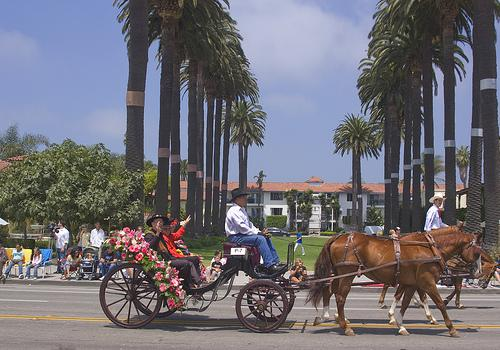Question: what are the horses pulling?
Choices:
A. A cart.
B. A plow.
C. A carriage.
D. A float in the parade.
Answer with the letter. Answer: C Question: what are the two people riding in the back of the carriage doing?
Choices:
A. Smiling.
B. Laughing.
C. Eating.
D. Waving.
Answer with the letter. Answer: D Question: where are the horses and the carriage?
Choices:
A. Down the road a block.
B. On the gravel road.
C. In the middle of the street.
D. In the grass pulled off to the side.
Answer with the letter. Answer: C Question: what kind of trees are the tall ones?
Choices:
A. Pine.
B. Oak.
C. Palm.
D. Maple.
Answer with the letter. Answer: C Question: how are horses pulling the carriage?
Choices:
A. By walking.
B. By wearing harnesses.
C. By trotting.
D. By running.
Answer with the letter. Answer: B Question: when was this picture taken?
Choices:
A. The daytime.
B. At night.
C. At sunrise.
D. At evening.
Answer with the letter. Answer: A 